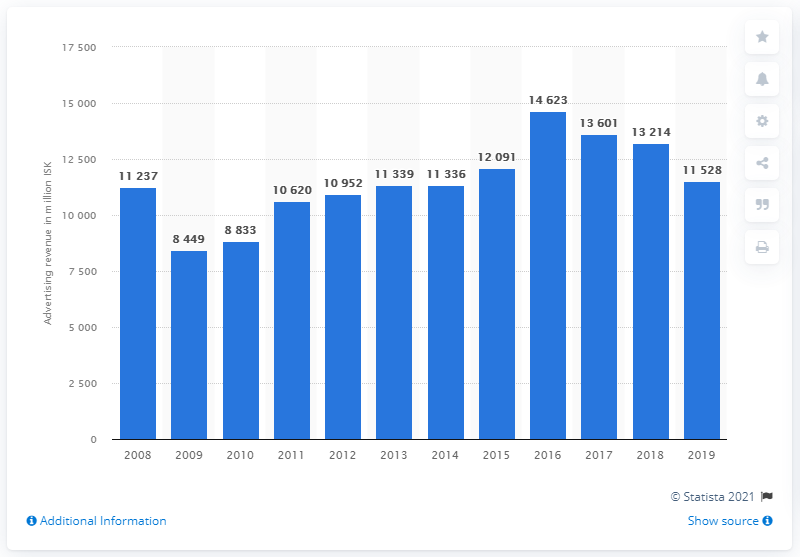Specify some key components in this picture. The latest data from 2019 indicates a value of 11,528 Icelandic krónur. In 2016, Iceland's advertising revenue was approximately 14,623. 